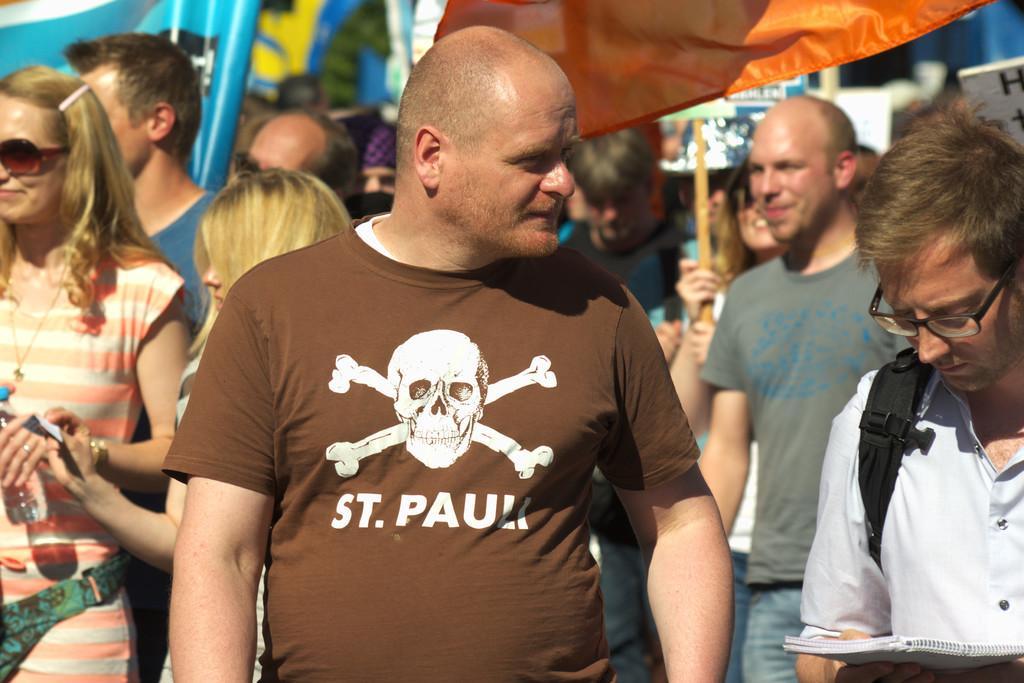Could you give a brief overview of what you see in this image? In this image, we can see a group of people. In the background, we can see an orange color cloth and a board which is holed by a person, metal rod. 